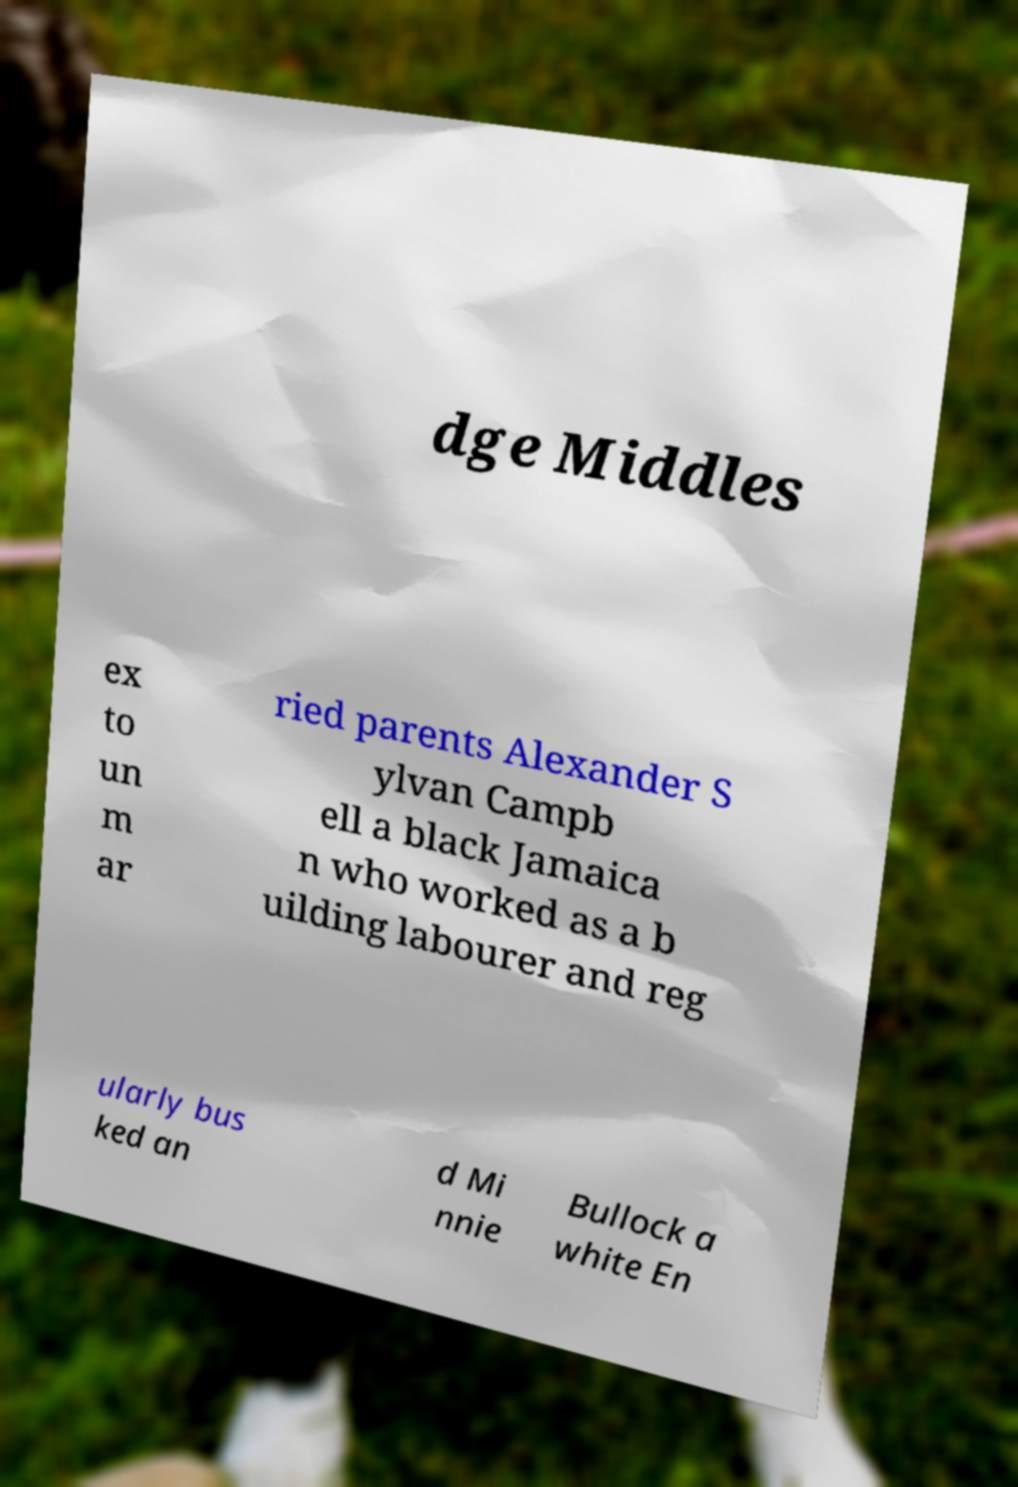Please read and relay the text visible in this image. What does it say? dge Middles ex to un m ar ried parents Alexander S ylvan Campb ell a black Jamaica n who worked as a b uilding labourer and reg ularly bus ked an d Mi nnie Bullock a white En 